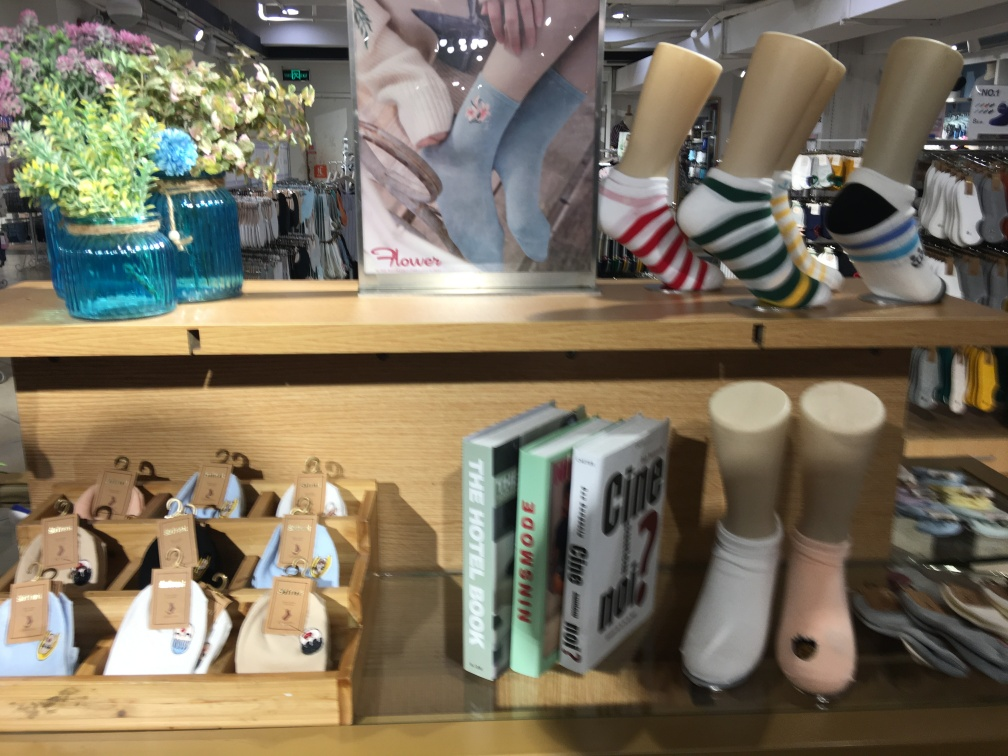Do the items on display suggest what type of store this might be? The items suggest that this is likely a lifestyle or boutique store catering to customers interested in fashion, home decor, and travel. The combination of reading material, wearable items, and home accents points to a store that sells a curated collection of trendy and stylish goods. 